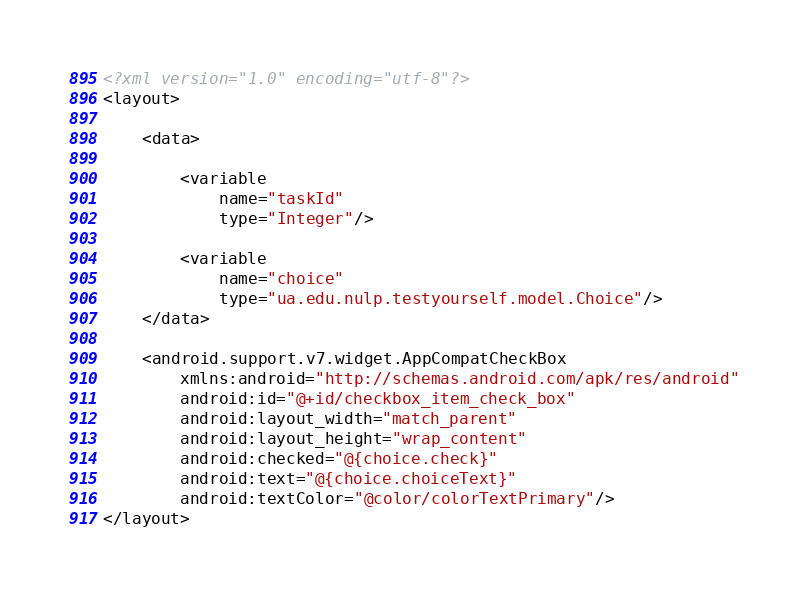<code> <loc_0><loc_0><loc_500><loc_500><_XML_><?xml version="1.0" encoding="utf-8"?>
<layout>

    <data>

        <variable
            name="taskId"
            type="Integer"/>

        <variable
            name="choice"
            type="ua.edu.nulp.testyourself.model.Choice"/>
    </data>

    <android.support.v7.widget.AppCompatCheckBox
        xmlns:android="http://schemas.android.com/apk/res/android"
        android:id="@+id/checkbox_item_check_box"
        android:layout_width="match_parent"
        android:layout_height="wrap_content"
        android:checked="@{choice.check}"
        android:text="@{choice.choiceText}"
        android:textColor="@color/colorTextPrimary"/>
</layout></code> 